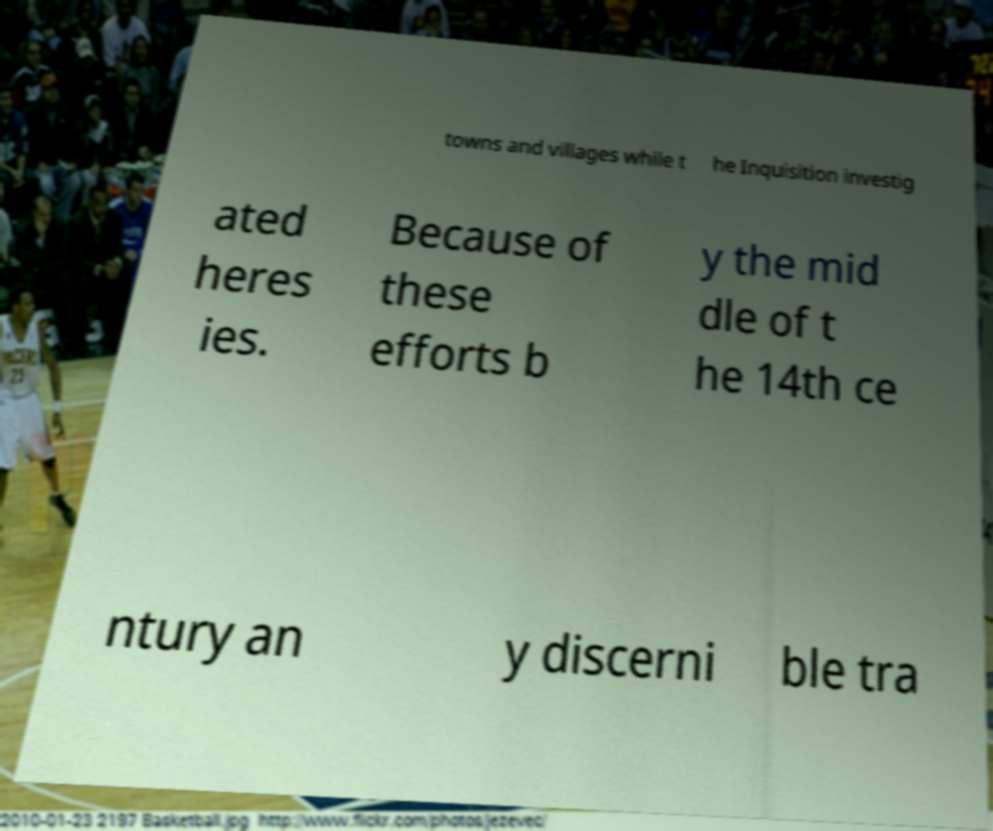Please identify and transcribe the text found in this image. towns and villages while t he Inquisition investig ated heres ies. Because of these efforts b y the mid dle of t he 14th ce ntury an y discerni ble tra 